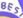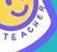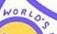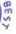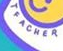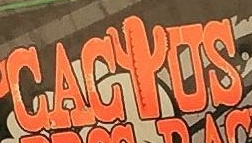What words are shown in these images in order, separated by a semicolon? BES; TEACHER; WORLO'S; BEST; TEACHER; CACIUS 